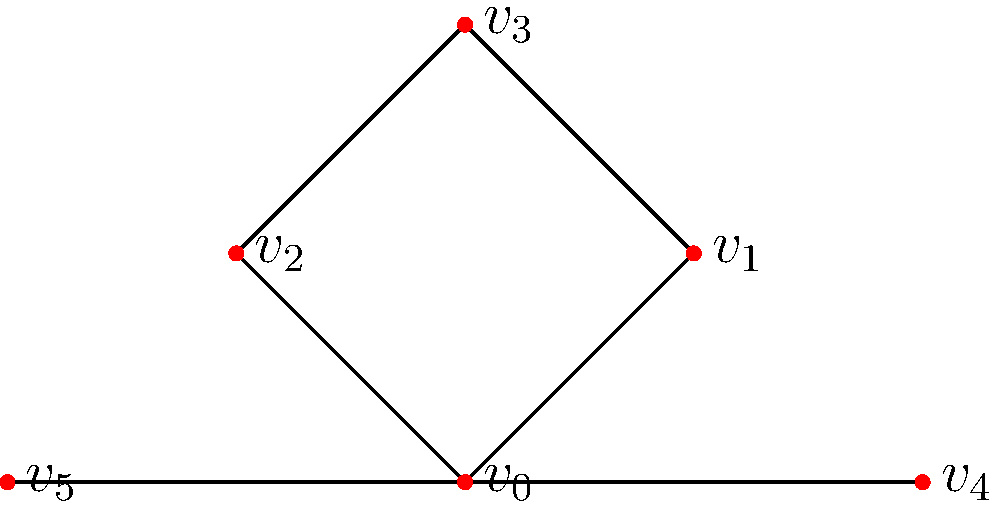In the context of analyzing social media influencer networks for potential marketing strategies, consider the graph above representing influencers and their follower relationships. If $v_0$ represents a key influencer in a startup's target market, what is the betweenness centrality of $v_0$? To calculate the betweenness centrality of $v_0$, we need to follow these steps:

1) Identify all pairs of vertices that $v_0$ lies on the shortest path between:
   $(v_1, v_4)$, $(v_1, v_5)$, $(v_2, v_4)$, $(v_2, v_5)$, $(v_3, v_4)$, $(v_3, v_5)$, $(v_4, v_5)$

2) Count the number of shortest paths between each pair:
   All these pairs have only one shortest path through $v_0$.

3) Sum up the fraction of shortest paths that pass through $v_0$:
   For each pair, the fraction is 1, as all shortest paths go through $v_0$.

4) Calculate the betweenness centrality:
   $B(v_0) = \sum_{s \neq v_0 \neq t} \frac{\sigma_{st}(v_0)}{\sigma_{st}}$
   
   Where $\sigma_{st}$ is the total number of shortest paths from node $s$ to node $t$, and $\sigma_{st}(v_0)$ is the number of those paths that pass through $v_0$.

5) In this case:
   $B(v_0) = 1 + 1 + 1 + 1 + 1 + 1 + 1 = 7$

This high betweenness centrality indicates that $v_0$ is a crucial connector in the network, potentially representing an influencer with significant reach across different subgroups in the startup's target market.
Answer: 7 